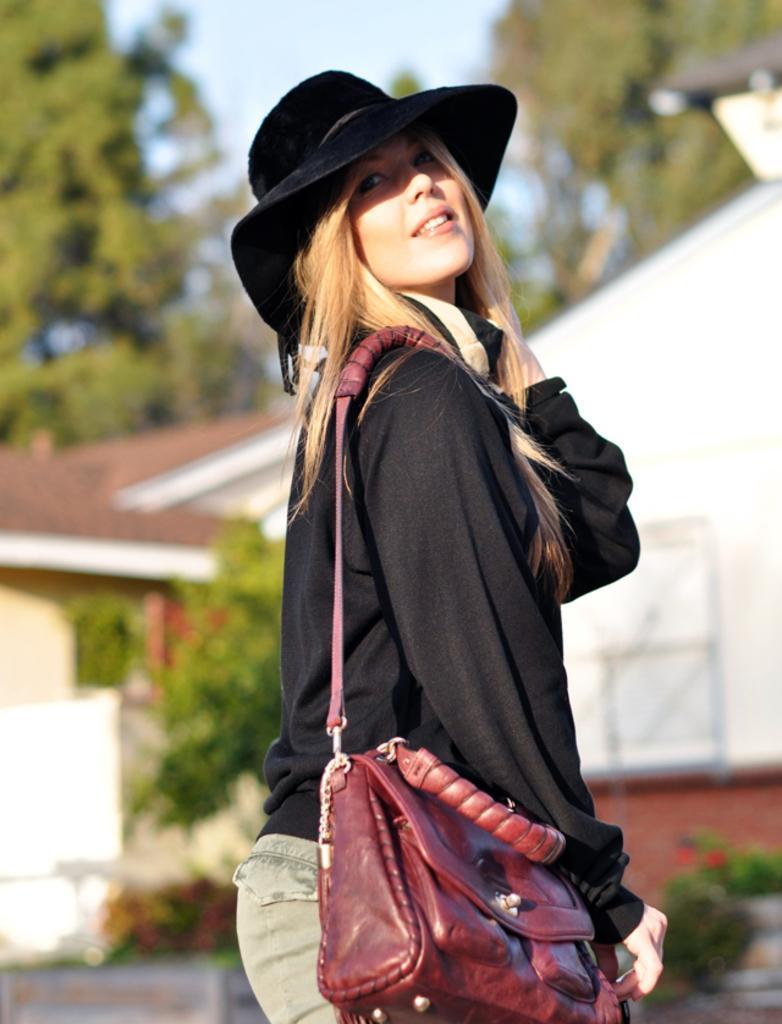How would you summarize this image in a sentence or two? In the center we can see one woman she is standing and holding hand bag and she is wearing hat. In the background there is a tree,sky,house and wall. 